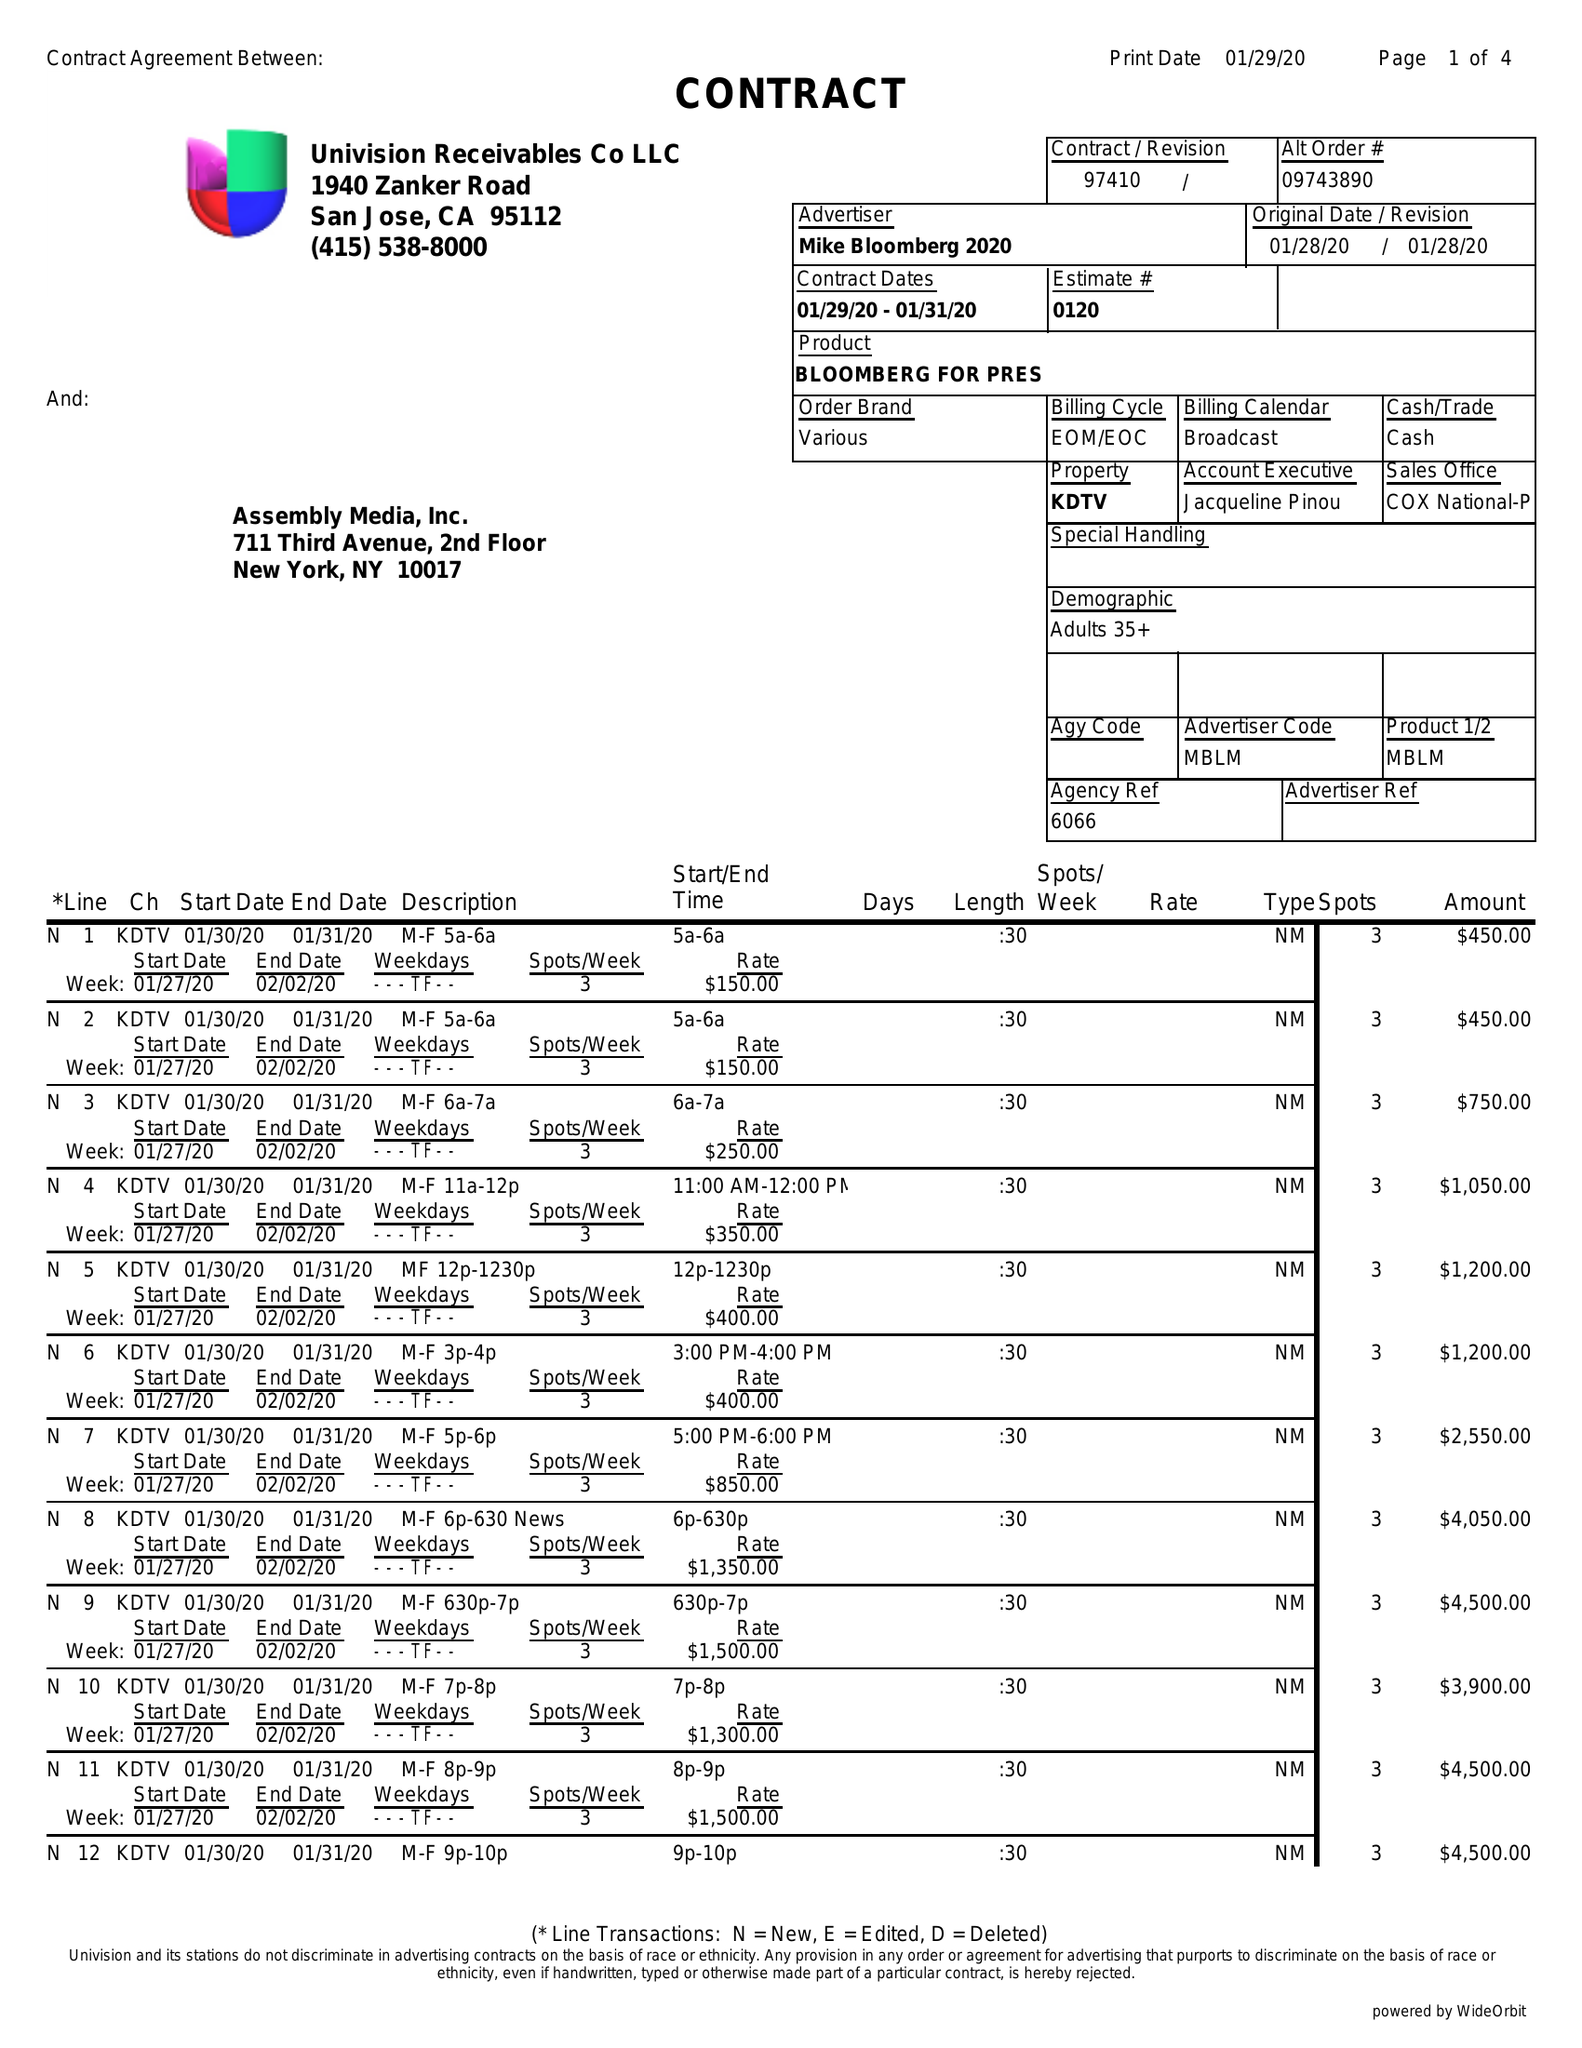What is the value for the flight_to?
Answer the question using a single word or phrase. 01/31/20 